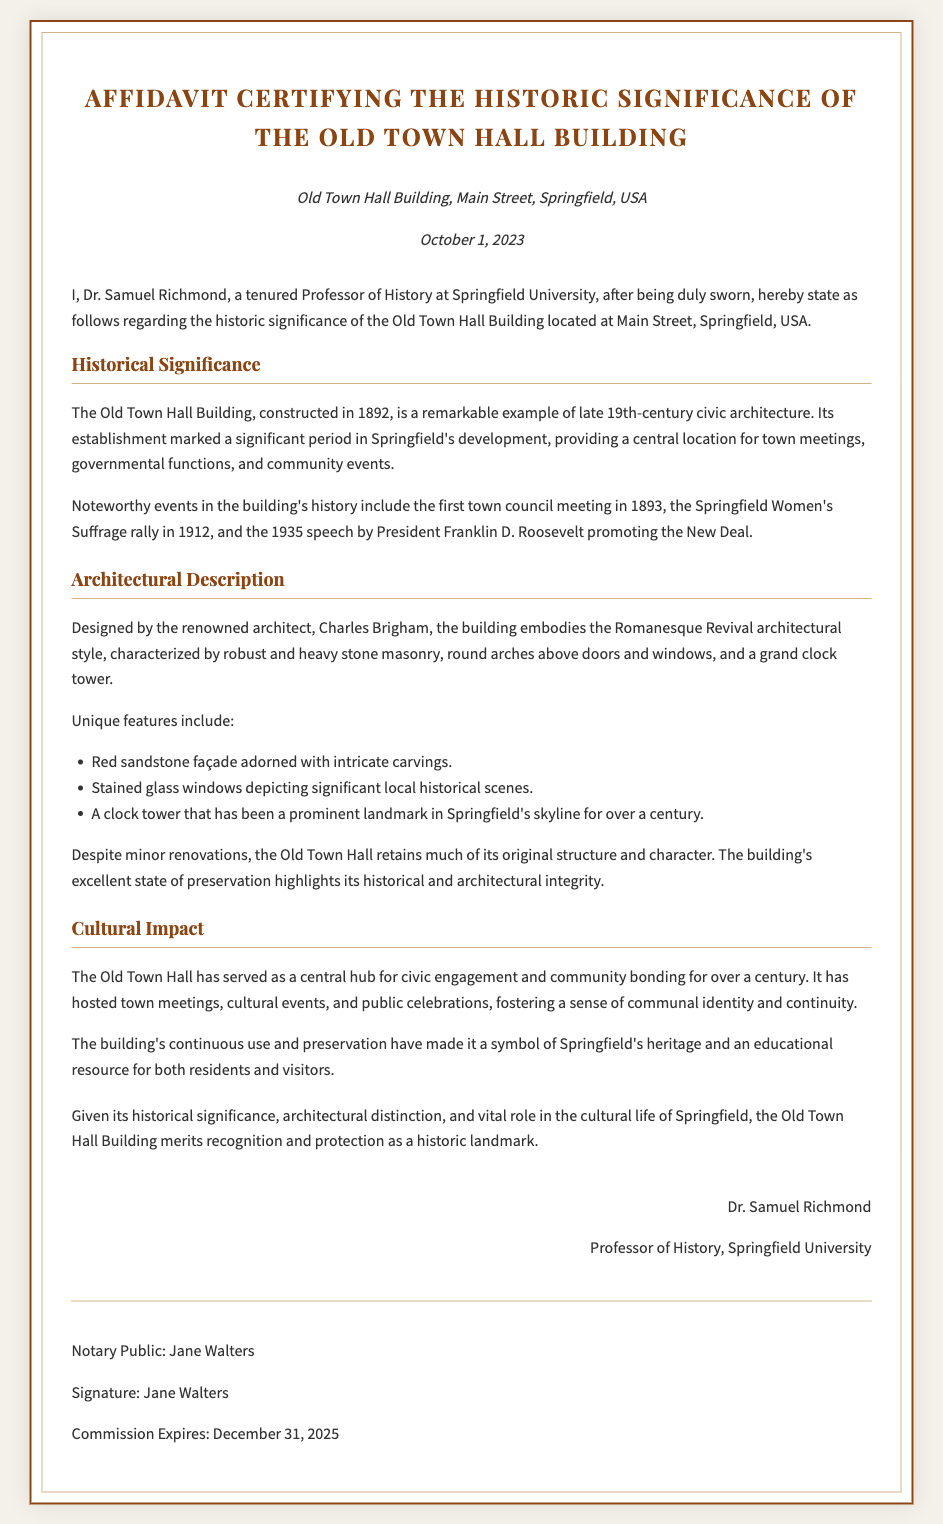What is the location of the Old Town Hall Building? The document specifies the Old Town Hall Building's location as Main Street, Springfield, USA.
Answer: Main Street, Springfield, USA Who is the signatory of the affidavit? The affidavit is signed by Dr. Samuel Richmond, who is identified as a Professor of History at Springfield University.
Answer: Dr. Samuel Richmond When was the Old Town Hall Building constructed? The document states that the Old Town Hall Building was constructed in 1892.
Answer: 1892 What architectural style is the Old Town Hall Building designed in? The affidavit describes the architectural style of the Old Town Hall Building as Romanesque Revival.
Answer: Romanesque Revival What significant event happened in 1912 at the Old Town Hall? The document mentions that the Springfield Women's Suffrage rally took place in 1912 at the Old Town Hall.
Answer: Springfield Women's Suffrage rally What unique feature does the building's clock tower represent? The clock tower has been a prominent landmark in Springfield's skyline for over a century, as stated in the affidavit.
Answer: Prominent landmark What is the role of the Old Town Hall Building in the community? The document discusses that the building has served as a central hub for civic engagement and community bonding for over a century.
Answer: Civic engagement and community bonding Who notarized the affidavit? The notary public named in the document is Jane Walters.
Answer: Jane Walters What is the expiration date of the notary's commission? The affidavit states that the notary's commission expires on December 31, 2025.
Answer: December 31, 2025 